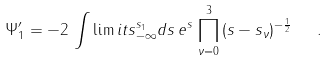Convert formula to latex. <formula><loc_0><loc_0><loc_500><loc_500>\Psi ^ { \prime } _ { 1 } = - 2 \, \int \lim i t s _ { - \infty } ^ { s _ { 1 } } d s \, e ^ { s } \, \prod _ { \nu = 0 } ^ { 3 } \, ( s - s _ { \nu } ) ^ { - \frac { 1 } { 2 } } \ \ .</formula> 